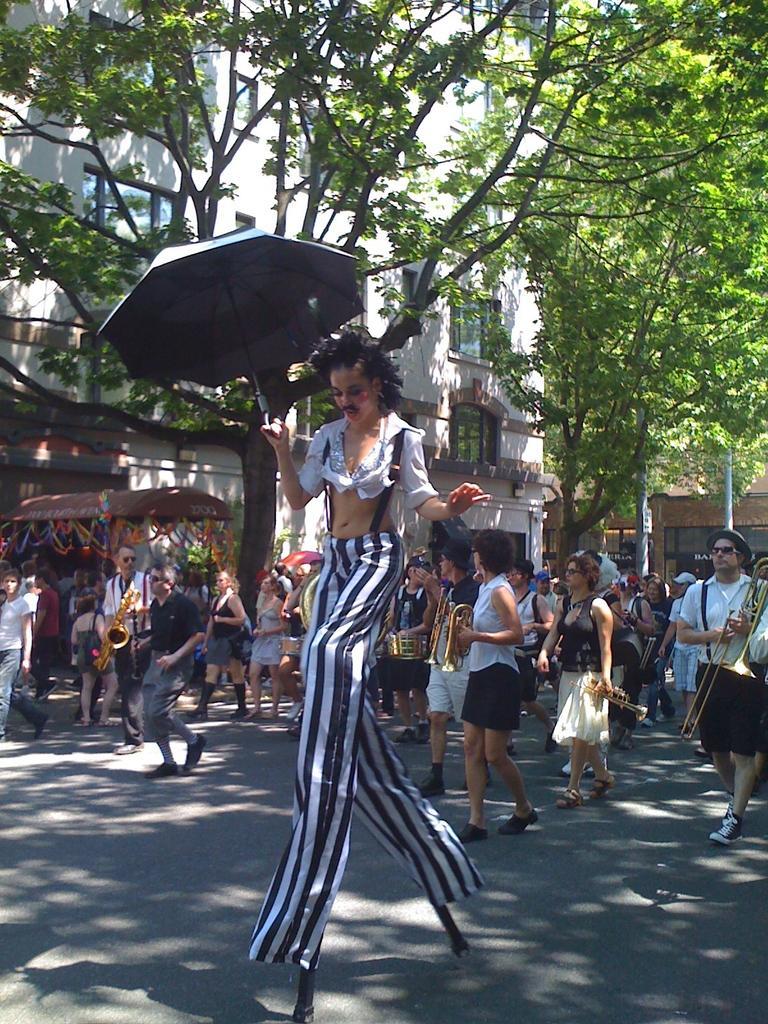Could you give a brief overview of what you see in this image? This image is taken outdoors. At the bottom of the image there is a road. In the background there is a building with walls, windows and doors. There are two trees with green leaves, stems and branches and there is a pole. In the middle of the image a few people are walking on the road and a few are holding musical instruments in their hands. A tall woman is walking on the road and she is holding an umbrella in her hand. 